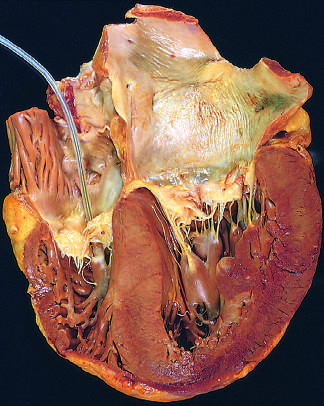s low-power view of a cross section of a skin blister showing the epidermis marked concentric thickening of the left ventricular wall causing reduction in lumen size?
Answer the question using a single word or phrase. No 